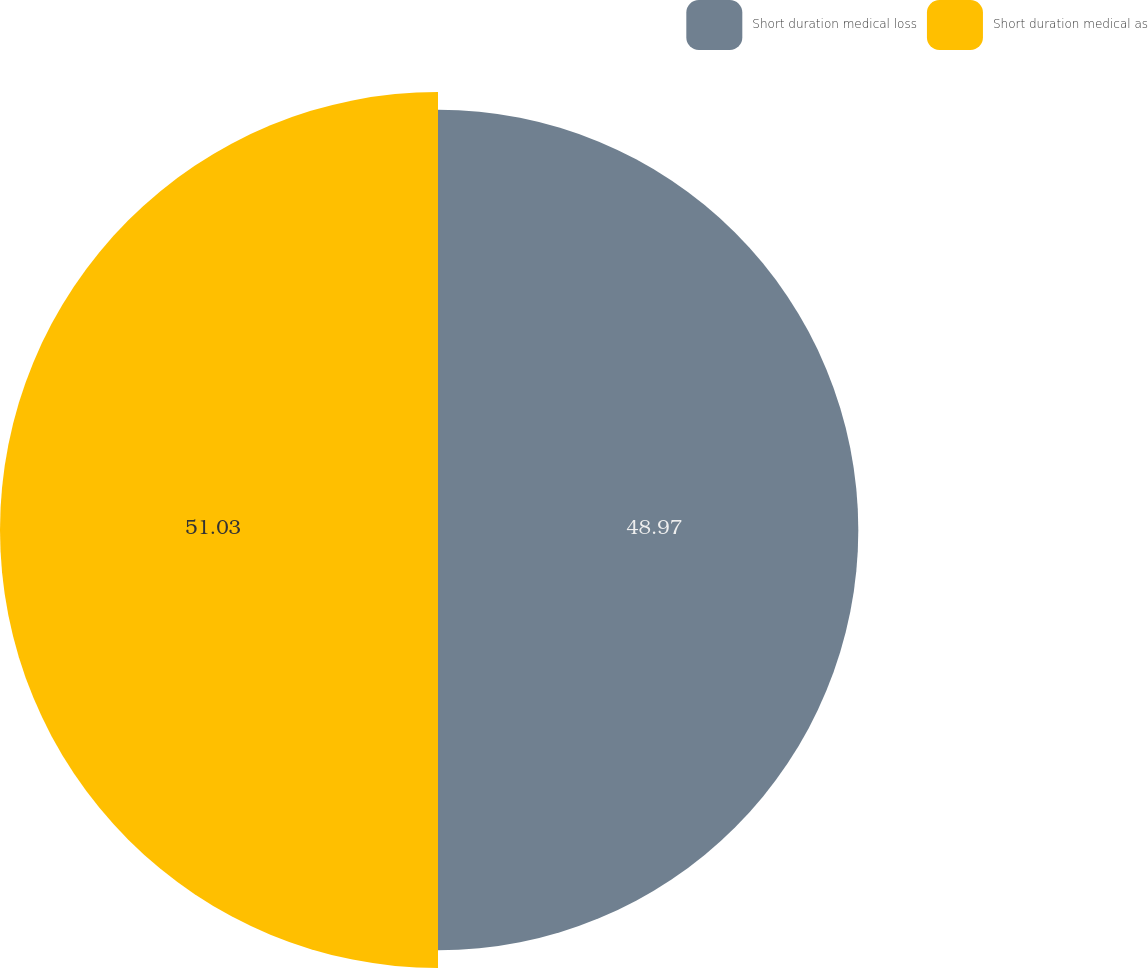Convert chart. <chart><loc_0><loc_0><loc_500><loc_500><pie_chart><fcel>Short duration medical loss<fcel>Short duration medical as<nl><fcel>48.97%<fcel>51.03%<nl></chart> 